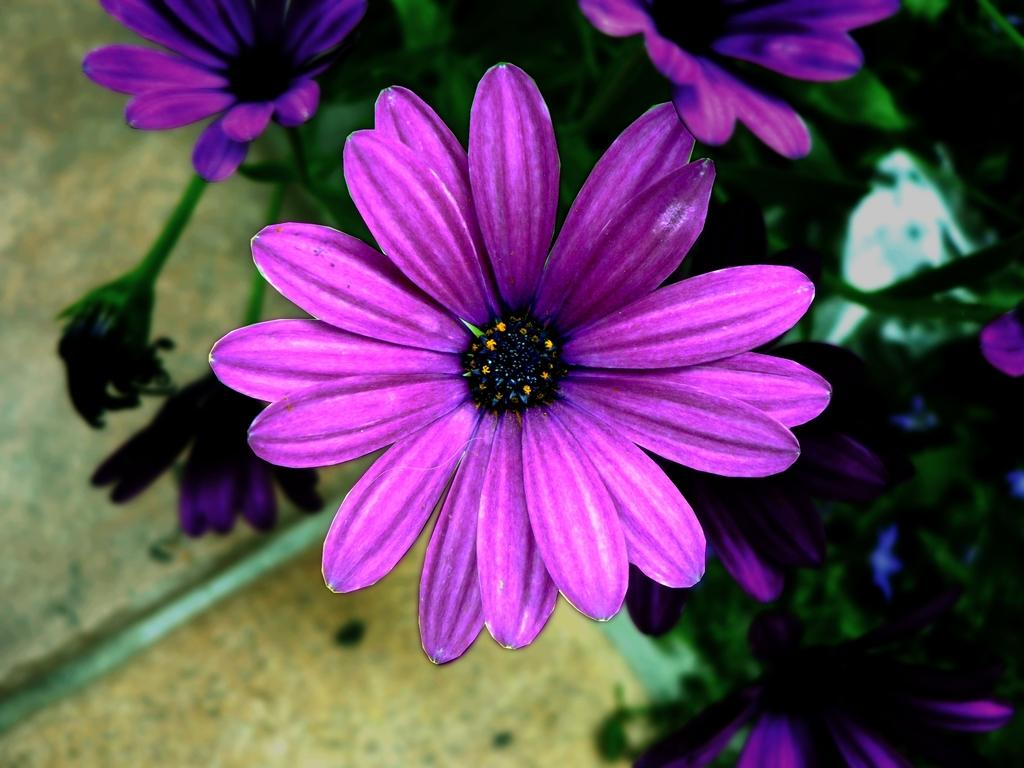What type of plants can be seen in the image? There are plants with flowers in the image. What part of the image shows the surface on which the plants are growing? The ground is visible at the bottom of the image. What color is the thread that is woven through the flowers in the image? There is no thread woven through the flowers in the image. Where is the toad located in the image? There is no toad present in the image. 